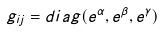Convert formula to latex. <formula><loc_0><loc_0><loc_500><loc_500>g _ { i j } = d i a g ( e ^ { \alpha } , e ^ { \beta } , e ^ { \gamma } )</formula> 